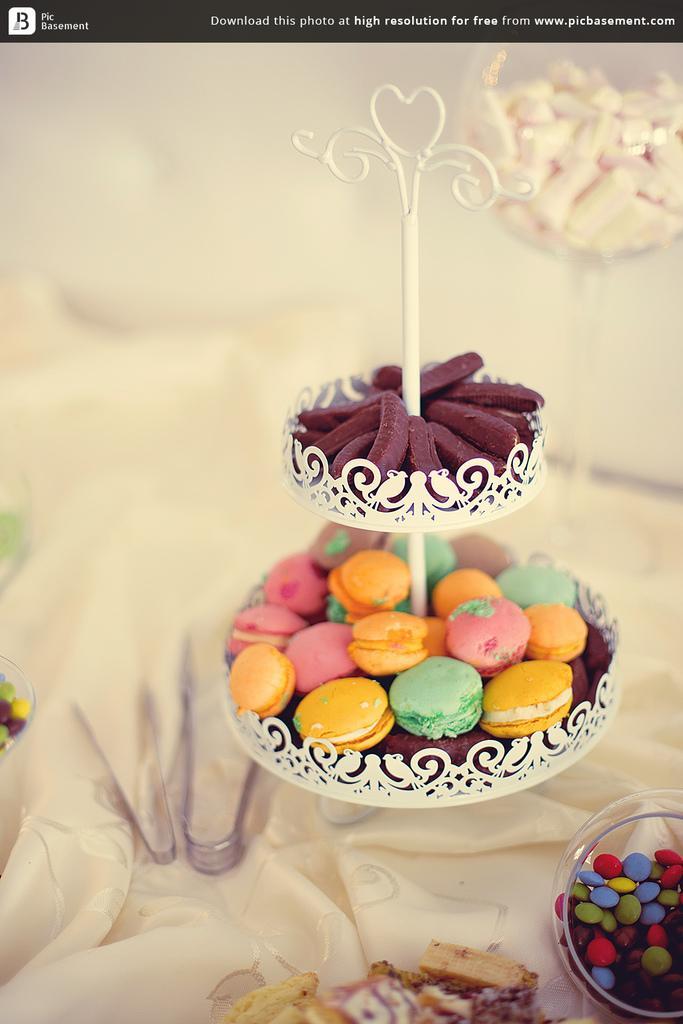Could you give a brief overview of what you see in this image? In this image I can see candies in different bowls and two forceps and at the top of the image I can see some text. 